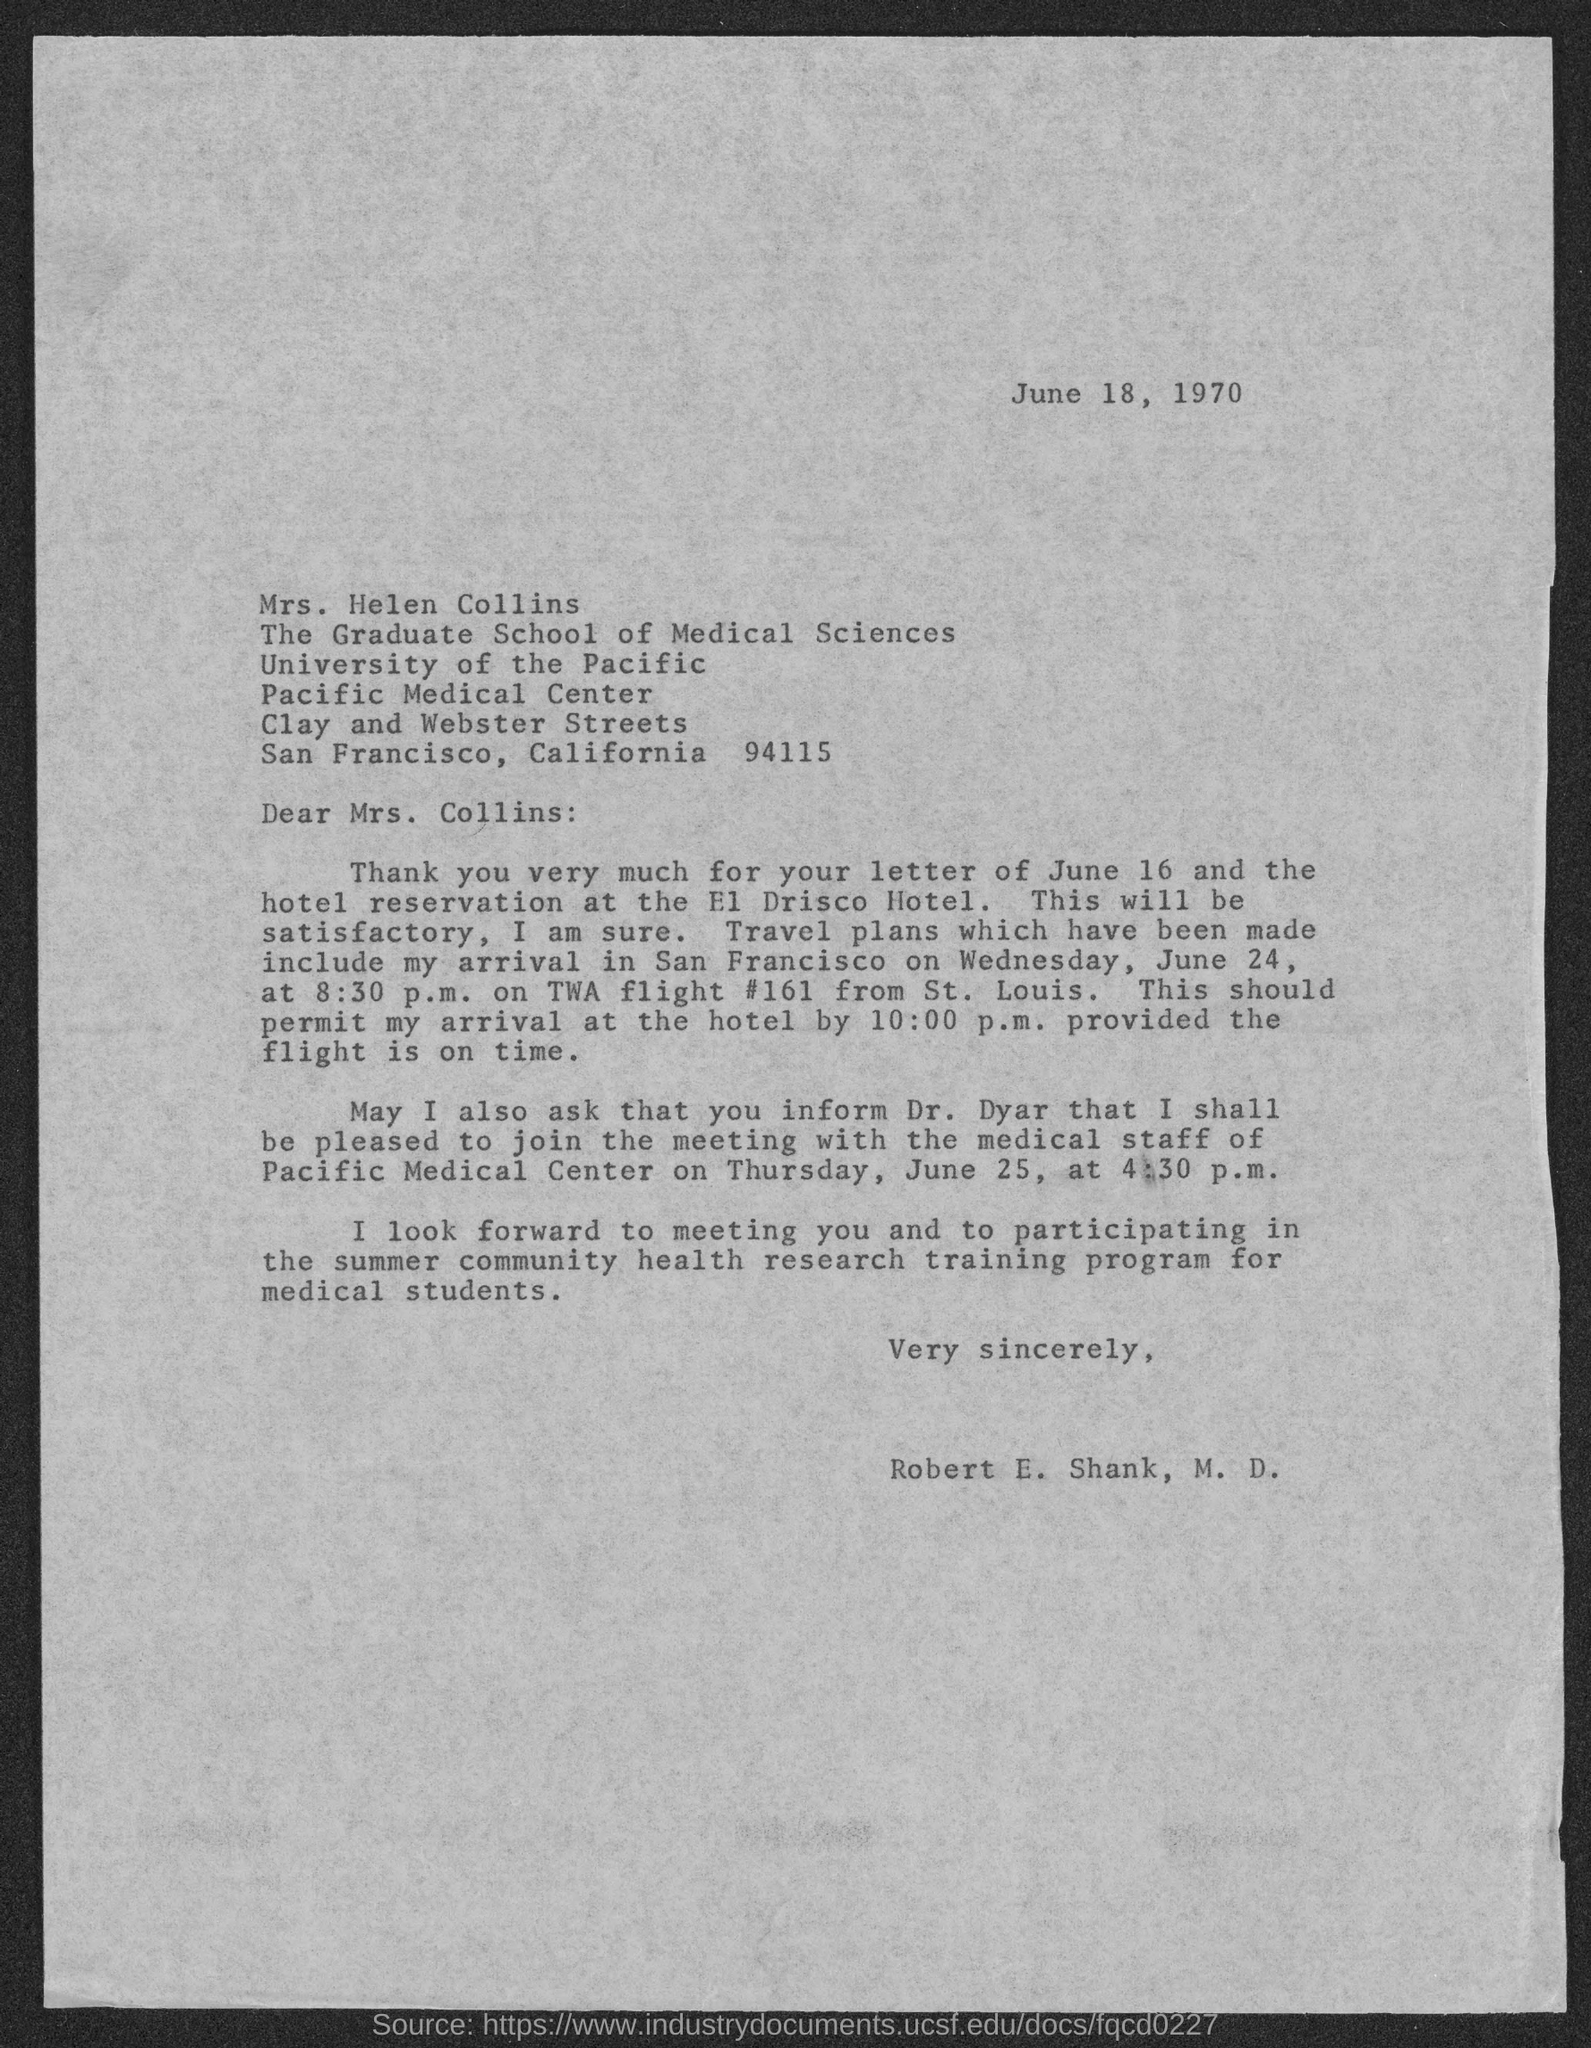Mention a couple of crucial points in this snapshot. This letter was written by Robert E. Shank, M.D. This letter is addressed to Mrs. Helen Collins. The TWA flight #161 is originating from St. Louis. 